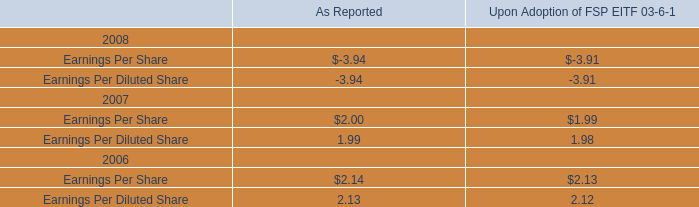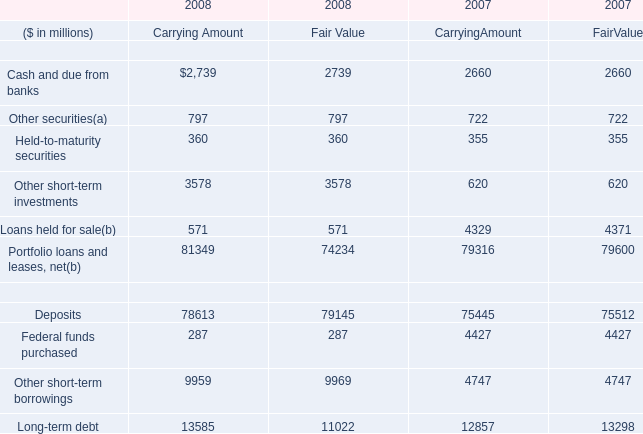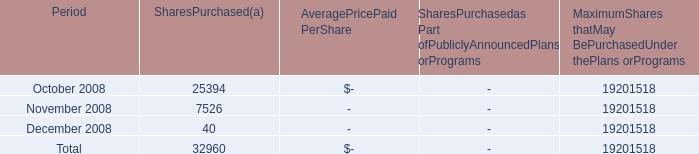what is the highest total amount of Other securities? (in million) 
Computations: (((797 + 797) + 722) + 722)
Answer: 3038.0. 